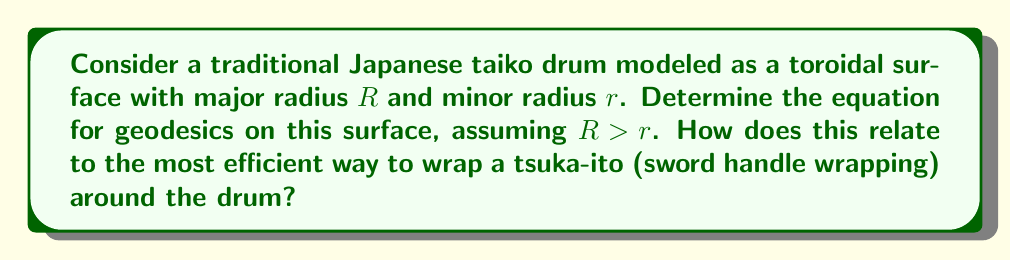Provide a solution to this math problem. To solve this problem, we'll follow these steps:

1) The parametric equations for a torus with major radius $R$ and minor radius $r$ are:

   $$x = (R + r\cos v)\cos u$$
   $$y = (R + r\cos v)\sin u$$
   $$z = r\sin v$$

   where $0 \leq u, v < 2\pi$

2) The metric tensor for this surface is:

   $$g_{11} = (R + r\cos v)^2$$
   $$g_{12} = g_{21} = 0$$
   $$g_{22} = r^2$$

3) The geodesic equations for this surface are:

   $$\frac{d^2u}{ds^2} + \frac{2r\sin v}{R + r\cos v}\frac{du}{ds}\frac{dv}{ds} = 0$$
   $$\frac{d^2v}{ds^2} - \frac{(R + r\cos v)\sin v}{r}\left(\frac{du}{ds}\right)^2 = 0$$

4) These equations can be simplified using the first integral of the geodesic equations:

   $$(R + r\cos v)^2\left(\frac{du}{ds}\right) = c$$

   where $c$ is a constant.

5) Substituting this into the second equation:

   $$\frac{d^2v}{ds^2} - \frac{c^2\sin v}{r(R + r\cos v)^3} = 0$$

6) This equation describes the geodesics on the toroidal surface. The solution depends on the constant $c$, which is related to the initial conditions.

7) For a tsuka-ito wrapping, we want the most efficient path around the drum. This corresponds to a geodesic with a constant angle to the meridians of the torus, given by:

   $$\tan\alpha = \frac{R}{r}\sin\beta$$

   where $\alpha$ is the angle with the meridian and $\beta$ is a constant.

This solution relates to the efficient wrapping of a tsuka-ito around the drum, as it provides the shortest path between two points on the surface, minimizing material use and maximizing stability.
Answer: $\frac{d^2v}{ds^2} - \frac{c^2\sin v}{r(R + r\cos v)^3} = 0$, with $\tan\alpha = \frac{R}{r}\sin\beta$ for constant-angle wrapping. 